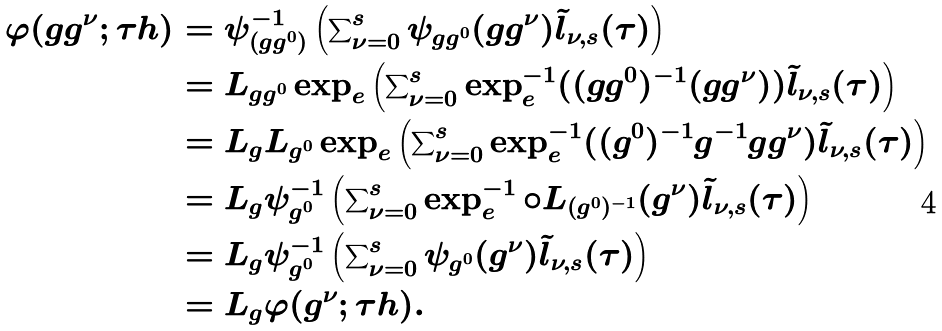<formula> <loc_0><loc_0><loc_500><loc_500>\varphi ( g g ^ { \nu } ; \tau h ) & = \psi _ { ( g g ^ { 0 } ) } ^ { - 1 } \left ( \sum \nolimits _ { \nu = 0 } ^ { s } \psi _ { g g ^ { 0 } } ( g g ^ { \nu } ) \tilde { l } _ { \nu , s } ( \tau ) \right ) \\ & = L _ { g g ^ { 0 } } \exp _ { e } \left ( \sum \nolimits _ { \nu = 0 } ^ { s } \exp _ { e } ^ { - 1 } ( ( g g ^ { 0 } ) ^ { - 1 } ( g g ^ { \nu } ) ) \tilde { l } _ { \nu , s } ( \tau ) \right ) \\ & = L _ { g } L _ { g ^ { 0 } } \exp _ { e } \left ( \sum \nolimits _ { \nu = 0 } ^ { s } \exp _ { e } ^ { - 1 } ( ( g ^ { 0 } ) ^ { - 1 } g ^ { - 1 } g g ^ { \nu } ) \tilde { l } _ { \nu , s } ( \tau ) \right ) \\ & = L _ { g } \psi _ { g ^ { 0 } } ^ { - 1 } \left ( \sum \nolimits _ { \nu = 0 } ^ { s } \exp _ { e } ^ { - 1 } \circ L _ { ( g ^ { 0 } ) ^ { - 1 } } ( g ^ { \nu } ) \tilde { l } _ { \nu , s } ( \tau ) \right ) \\ & = L _ { g } \psi _ { g ^ { 0 } } ^ { - 1 } \left ( \sum \nolimits _ { \nu = 0 } ^ { s } \psi _ { g ^ { 0 } } ( g ^ { \nu } ) \tilde { l } _ { \nu , s } ( \tau ) \right ) \\ & = L _ { g } \varphi ( g ^ { \nu } ; \tau h ) .</formula> 